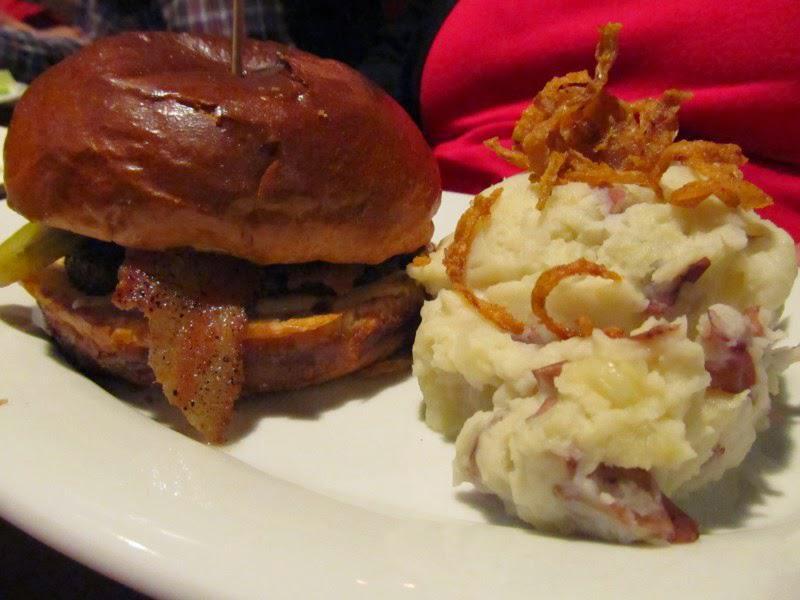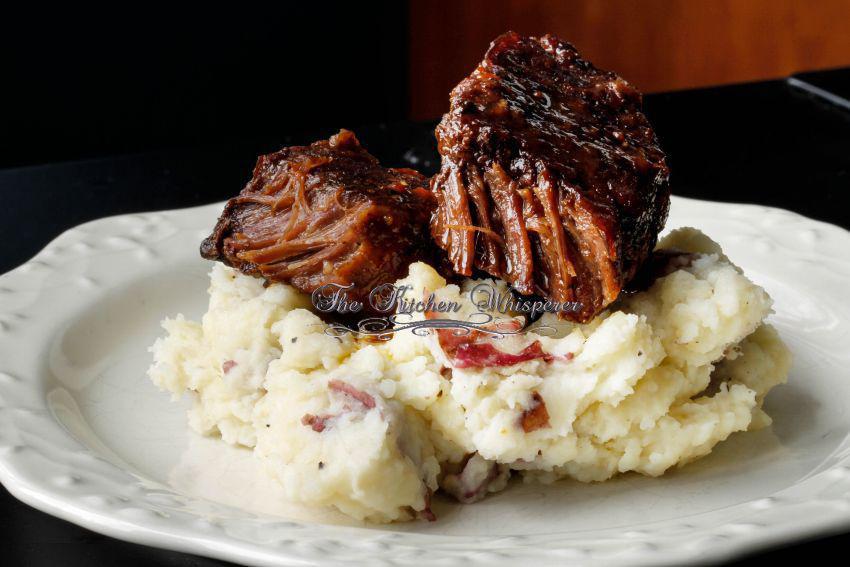The first image is the image on the left, the second image is the image on the right. For the images shown, is this caption "there is a visible orange vegetable in the image on the left side." true? Answer yes or no. No. The first image is the image on the left, the second image is the image on the right. Examine the images to the left and right. Is the description "There are absolutely NO forks present." accurate? Answer yes or no. Yes. 